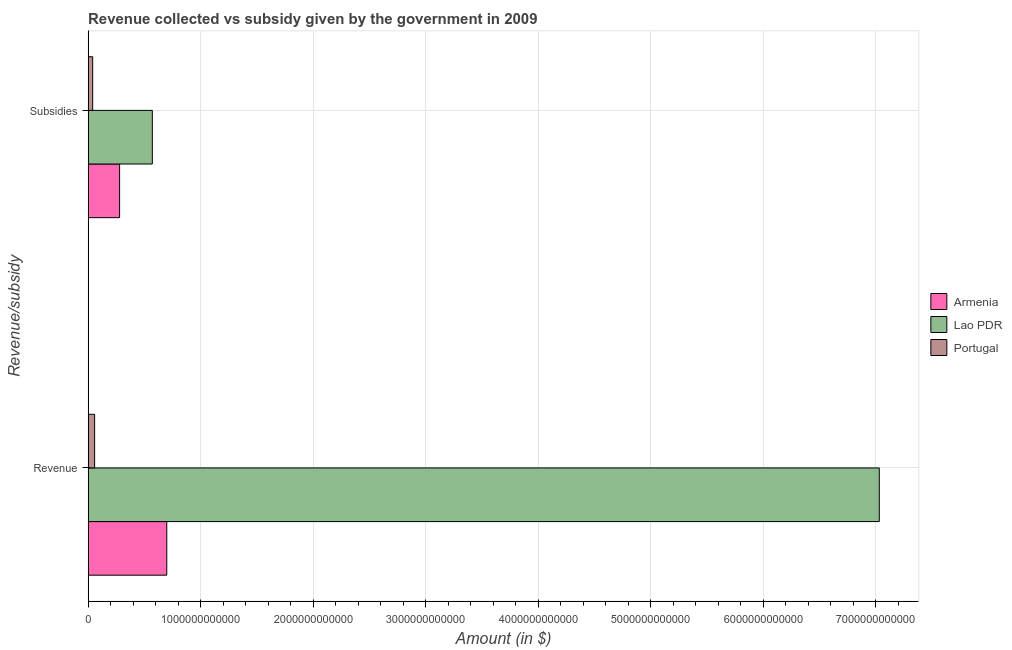How many groups of bars are there?
Offer a terse response. 2. Are the number of bars on each tick of the Y-axis equal?
Offer a very short reply. Yes. How many bars are there on the 1st tick from the top?
Make the answer very short. 3. What is the label of the 2nd group of bars from the top?
Provide a short and direct response. Revenue. What is the amount of revenue collected in Armenia?
Ensure brevity in your answer.  6.99e+11. Across all countries, what is the maximum amount of subsidies given?
Provide a short and direct response. 5.71e+11. Across all countries, what is the minimum amount of revenue collected?
Make the answer very short. 5.81e+1. In which country was the amount of subsidies given maximum?
Your answer should be compact. Lao PDR. In which country was the amount of subsidies given minimum?
Make the answer very short. Portugal. What is the total amount of revenue collected in the graph?
Ensure brevity in your answer.  7.79e+12. What is the difference between the amount of revenue collected in Armenia and that in Lao PDR?
Your response must be concise. -6.33e+12. What is the difference between the amount of subsidies given in Armenia and the amount of revenue collected in Lao PDR?
Ensure brevity in your answer.  -6.75e+12. What is the average amount of revenue collected per country?
Provide a succinct answer. 2.60e+12. What is the difference between the amount of revenue collected and amount of subsidies given in Portugal?
Keep it short and to the point. 1.72e+1. What is the ratio of the amount of revenue collected in Armenia to that in Lao PDR?
Provide a short and direct response. 0.1. Is the amount of subsidies given in Portugal less than that in Armenia?
Give a very brief answer. Yes. In how many countries, is the amount of revenue collected greater than the average amount of revenue collected taken over all countries?
Offer a terse response. 1. What does the 3rd bar from the top in Revenue represents?
Offer a terse response. Armenia. What does the 1st bar from the bottom in Subsidies represents?
Make the answer very short. Armenia. How many bars are there?
Give a very brief answer. 6. Are all the bars in the graph horizontal?
Your response must be concise. Yes. How many countries are there in the graph?
Give a very brief answer. 3. What is the difference between two consecutive major ticks on the X-axis?
Ensure brevity in your answer.  1.00e+12. Are the values on the major ticks of X-axis written in scientific E-notation?
Offer a terse response. No. Does the graph contain any zero values?
Your answer should be compact. No. Does the graph contain grids?
Provide a short and direct response. Yes. Where does the legend appear in the graph?
Make the answer very short. Center right. How many legend labels are there?
Keep it short and to the point. 3. What is the title of the graph?
Give a very brief answer. Revenue collected vs subsidy given by the government in 2009. Does "Faeroe Islands" appear as one of the legend labels in the graph?
Ensure brevity in your answer.  No. What is the label or title of the X-axis?
Provide a short and direct response. Amount (in $). What is the label or title of the Y-axis?
Offer a terse response. Revenue/subsidy. What is the Amount (in $) of Armenia in Revenue?
Provide a succinct answer. 6.99e+11. What is the Amount (in $) in Lao PDR in Revenue?
Provide a short and direct response. 7.03e+12. What is the Amount (in $) in Portugal in Revenue?
Offer a very short reply. 5.81e+1. What is the Amount (in $) of Armenia in Subsidies?
Offer a very short reply. 2.80e+11. What is the Amount (in $) of Lao PDR in Subsidies?
Give a very brief answer. 5.71e+11. What is the Amount (in $) in Portugal in Subsidies?
Offer a terse response. 4.09e+1. Across all Revenue/subsidy, what is the maximum Amount (in $) of Armenia?
Provide a short and direct response. 6.99e+11. Across all Revenue/subsidy, what is the maximum Amount (in $) in Lao PDR?
Keep it short and to the point. 7.03e+12. Across all Revenue/subsidy, what is the maximum Amount (in $) in Portugal?
Provide a succinct answer. 5.81e+1. Across all Revenue/subsidy, what is the minimum Amount (in $) in Armenia?
Offer a very short reply. 2.80e+11. Across all Revenue/subsidy, what is the minimum Amount (in $) in Lao PDR?
Provide a short and direct response. 5.71e+11. Across all Revenue/subsidy, what is the minimum Amount (in $) in Portugal?
Offer a very short reply. 4.09e+1. What is the total Amount (in $) in Armenia in the graph?
Offer a terse response. 9.79e+11. What is the total Amount (in $) of Lao PDR in the graph?
Keep it short and to the point. 7.60e+12. What is the total Amount (in $) of Portugal in the graph?
Provide a succinct answer. 9.89e+1. What is the difference between the Amount (in $) of Armenia in Revenue and that in Subsidies?
Give a very brief answer. 4.19e+11. What is the difference between the Amount (in $) in Lao PDR in Revenue and that in Subsidies?
Ensure brevity in your answer.  6.46e+12. What is the difference between the Amount (in $) in Portugal in Revenue and that in Subsidies?
Make the answer very short. 1.72e+1. What is the difference between the Amount (in $) of Armenia in Revenue and the Amount (in $) of Lao PDR in Subsidies?
Your response must be concise. 1.28e+11. What is the difference between the Amount (in $) of Armenia in Revenue and the Amount (in $) of Portugal in Subsidies?
Offer a very short reply. 6.58e+11. What is the difference between the Amount (in $) of Lao PDR in Revenue and the Amount (in $) of Portugal in Subsidies?
Your response must be concise. 6.99e+12. What is the average Amount (in $) of Armenia per Revenue/subsidy?
Give a very brief answer. 4.90e+11. What is the average Amount (in $) in Lao PDR per Revenue/subsidy?
Offer a very short reply. 3.80e+12. What is the average Amount (in $) of Portugal per Revenue/subsidy?
Your answer should be compact. 4.95e+1. What is the difference between the Amount (in $) of Armenia and Amount (in $) of Lao PDR in Revenue?
Ensure brevity in your answer.  -6.33e+12. What is the difference between the Amount (in $) of Armenia and Amount (in $) of Portugal in Revenue?
Offer a very short reply. 6.41e+11. What is the difference between the Amount (in $) of Lao PDR and Amount (in $) of Portugal in Revenue?
Your answer should be compact. 6.97e+12. What is the difference between the Amount (in $) of Armenia and Amount (in $) of Lao PDR in Subsidies?
Provide a short and direct response. -2.91e+11. What is the difference between the Amount (in $) of Armenia and Amount (in $) of Portugal in Subsidies?
Your answer should be compact. 2.39e+11. What is the difference between the Amount (in $) of Lao PDR and Amount (in $) of Portugal in Subsidies?
Offer a terse response. 5.30e+11. What is the ratio of the Amount (in $) in Armenia in Revenue to that in Subsidies?
Offer a terse response. 2.5. What is the ratio of the Amount (in $) in Lao PDR in Revenue to that in Subsidies?
Offer a very short reply. 12.32. What is the ratio of the Amount (in $) of Portugal in Revenue to that in Subsidies?
Ensure brevity in your answer.  1.42. What is the difference between the highest and the second highest Amount (in $) of Armenia?
Your response must be concise. 4.19e+11. What is the difference between the highest and the second highest Amount (in $) of Lao PDR?
Give a very brief answer. 6.46e+12. What is the difference between the highest and the second highest Amount (in $) in Portugal?
Make the answer very short. 1.72e+1. What is the difference between the highest and the lowest Amount (in $) of Armenia?
Your answer should be very brief. 4.19e+11. What is the difference between the highest and the lowest Amount (in $) of Lao PDR?
Offer a terse response. 6.46e+12. What is the difference between the highest and the lowest Amount (in $) in Portugal?
Keep it short and to the point. 1.72e+1. 